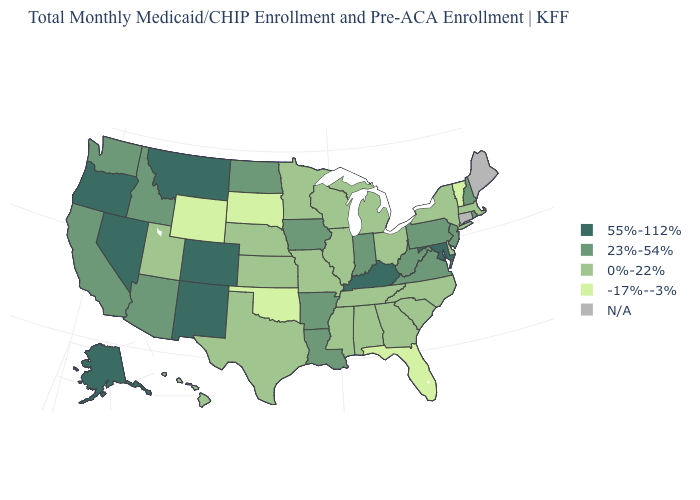Which states have the highest value in the USA?
Write a very short answer. Alaska, Colorado, Kentucky, Maryland, Montana, Nevada, New Mexico, Oregon. How many symbols are there in the legend?
Be succinct. 5. What is the value of Delaware?
Be succinct. 0%-22%. Among the states that border Pennsylvania , does West Virginia have the highest value?
Write a very short answer. No. What is the value of Alabama?
Give a very brief answer. 0%-22%. Does Florida have the lowest value in the USA?
Quick response, please. Yes. What is the lowest value in the USA?
Answer briefly. -17%--3%. What is the lowest value in states that border Florida?
Give a very brief answer. 0%-22%. Name the states that have a value in the range 23%-54%?
Keep it brief. Arizona, Arkansas, California, Idaho, Indiana, Iowa, Louisiana, New Hampshire, New Jersey, North Dakota, Pennsylvania, Rhode Island, Virginia, Washington, West Virginia. What is the value of Arkansas?
Concise answer only. 23%-54%. Which states have the lowest value in the MidWest?
Write a very short answer. South Dakota. What is the highest value in the West ?
Give a very brief answer. 55%-112%. What is the lowest value in the USA?
Concise answer only. -17%--3%. Among the states that border Alabama , which have the highest value?
Write a very short answer. Georgia, Mississippi, Tennessee. What is the value of Hawaii?
Write a very short answer. 0%-22%. 